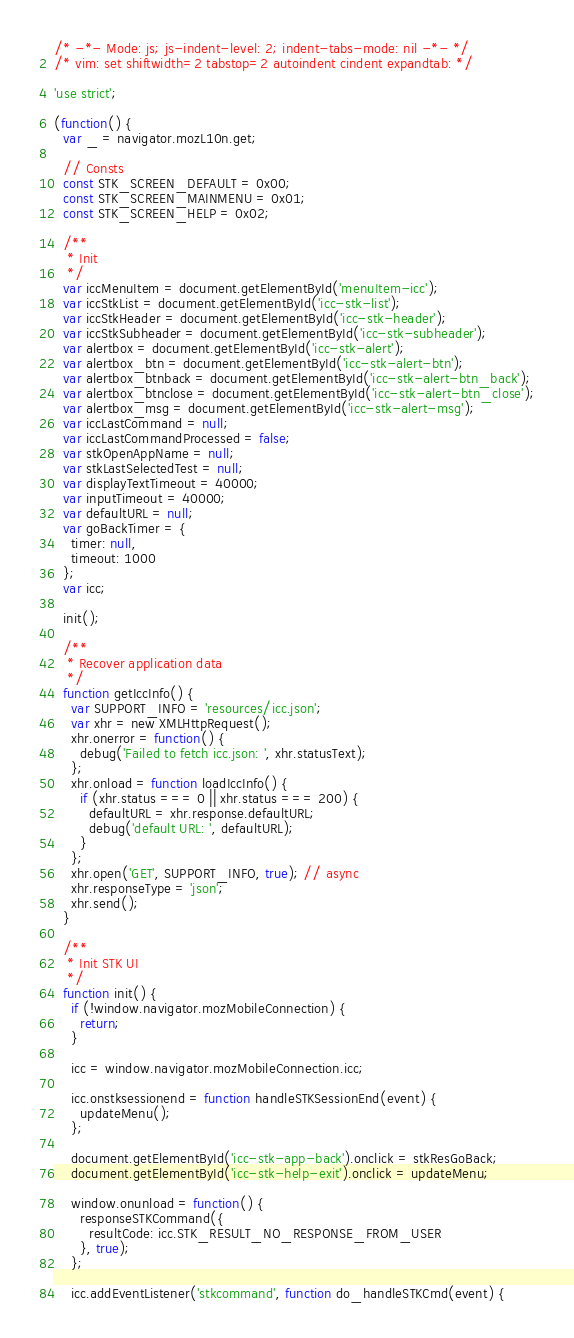<code> <loc_0><loc_0><loc_500><loc_500><_JavaScript_>/* -*- Mode: js; js-indent-level: 2; indent-tabs-mode: nil -*- */
/* vim: set shiftwidth=2 tabstop=2 autoindent cindent expandtab: */

'use strict';

(function() {
  var _ = navigator.mozL10n.get;

  // Consts
  const STK_SCREEN_DEFAULT = 0x00;
  const STK_SCREEN_MAINMENU = 0x01;
  const STK_SCREEN_HELP = 0x02;

  /**
   * Init
   */
  var iccMenuItem = document.getElementById('menuItem-icc');
  var iccStkList = document.getElementById('icc-stk-list');
  var iccStkHeader = document.getElementById('icc-stk-header');
  var iccStkSubheader = document.getElementById('icc-stk-subheader');
  var alertbox = document.getElementById('icc-stk-alert');
  var alertbox_btn = document.getElementById('icc-stk-alert-btn');
  var alertbox_btnback = document.getElementById('icc-stk-alert-btn_back');
  var alertbox_btnclose = document.getElementById('icc-stk-alert-btn_close');
  var alertbox_msg = document.getElementById('icc-stk-alert-msg');
  var iccLastCommand = null;
  var iccLastCommandProcessed = false;
  var stkOpenAppName = null;
  var stkLastSelectedTest = null;
  var displayTextTimeout = 40000;
  var inputTimeout = 40000;
  var defaultURL = null;
  var goBackTimer = {
    timer: null,
    timeout: 1000
  };
  var icc;

  init();

  /**
   * Recover application data
   */
  function getIccInfo() {
    var SUPPORT_INFO = 'resources/icc.json';
    var xhr = new XMLHttpRequest();
    xhr.onerror = function() {
      debug('Failed to fetch icc.json: ', xhr.statusText);
    };
    xhr.onload = function loadIccInfo() {
      if (xhr.status === 0 || xhr.status === 200) {
        defaultURL = xhr.response.defaultURL;
        debug('default URL: ', defaultURL);
      }
    };
    xhr.open('GET', SUPPORT_INFO, true); // async
    xhr.responseType = 'json';
    xhr.send();
  }

  /**
   * Init STK UI
   */
  function init() {
    if (!window.navigator.mozMobileConnection) {
      return;
    }

    icc = window.navigator.mozMobileConnection.icc;

    icc.onstksessionend = function handleSTKSessionEnd(event) {
      updateMenu();
    };

    document.getElementById('icc-stk-app-back').onclick = stkResGoBack;
    document.getElementById('icc-stk-help-exit').onclick = updateMenu;

    window.onunload = function() {
      responseSTKCommand({
        resultCode: icc.STK_RESULT_NO_RESPONSE_FROM_USER
      }, true);
    };

    icc.addEventListener('stkcommand', function do_handleSTKCmd(event) {</code> 